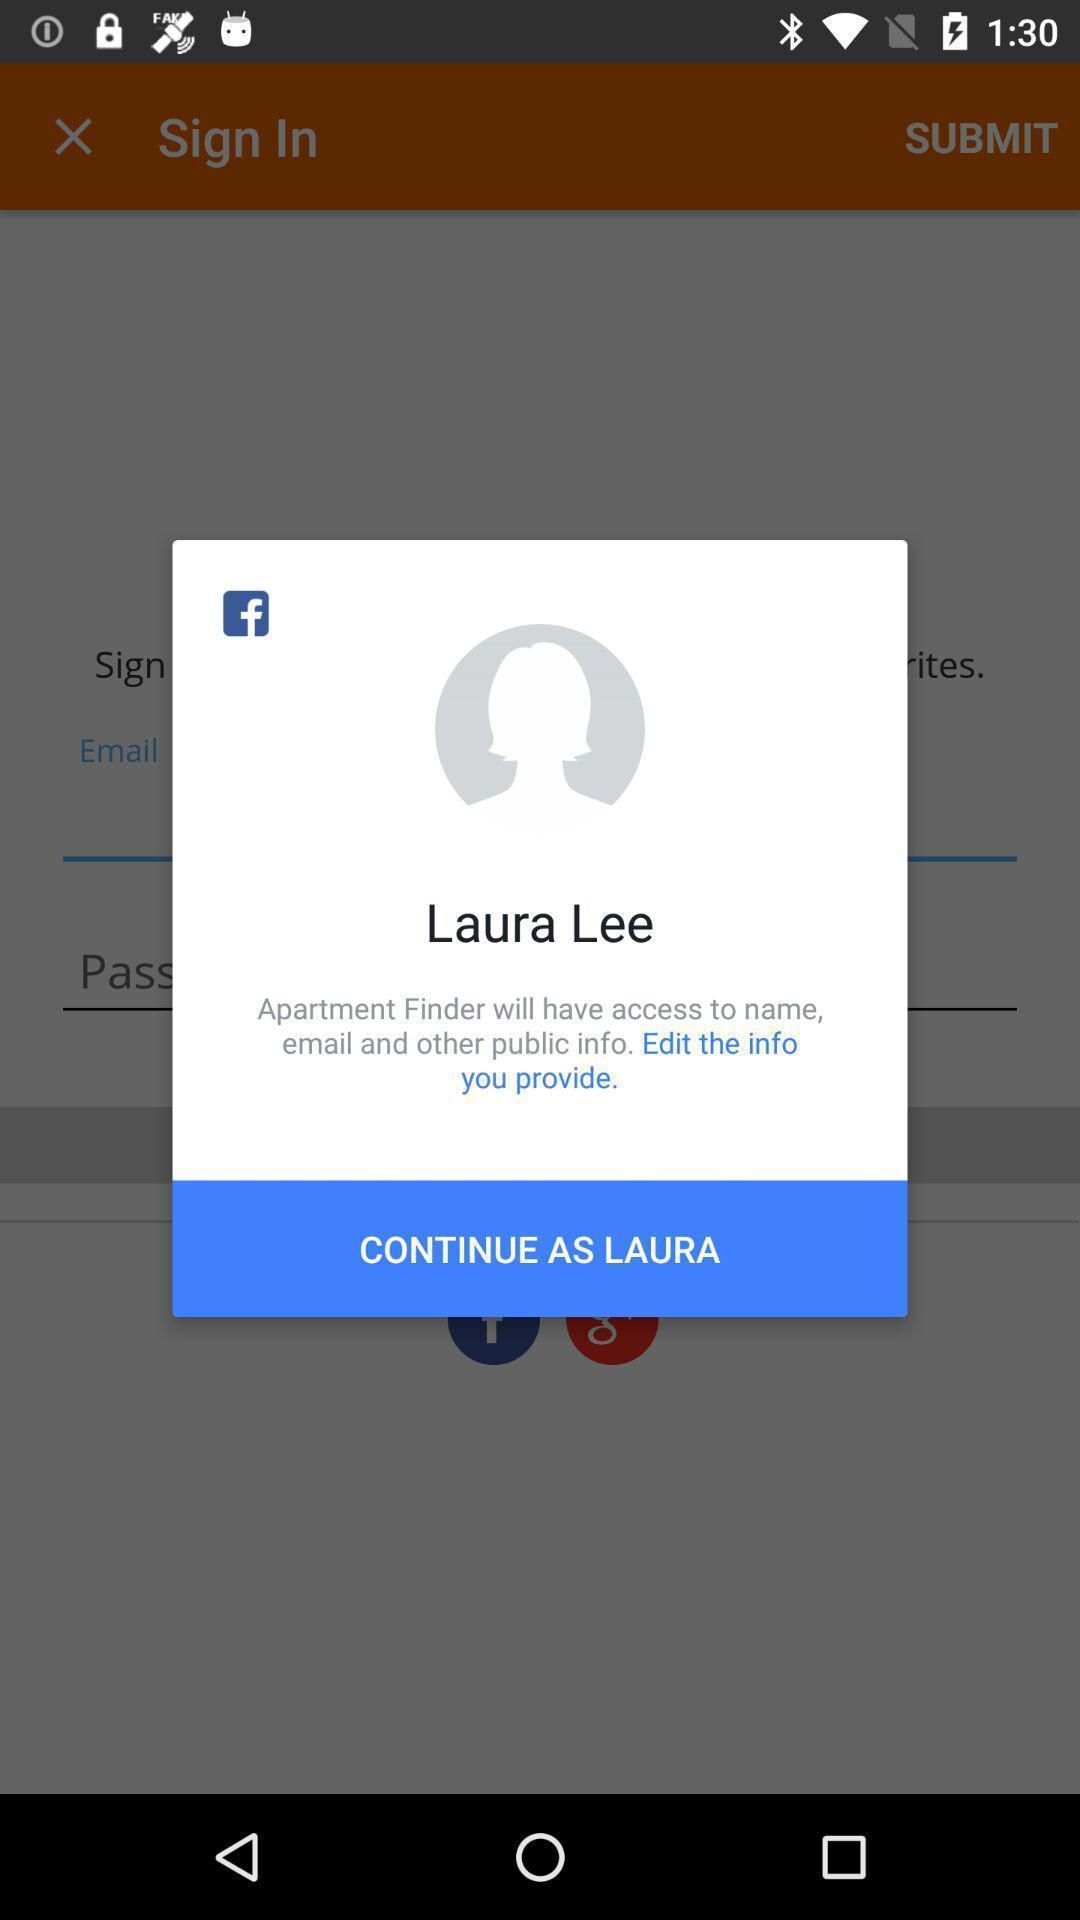Describe the content in this image. Pop-up showing privacy information about app. 